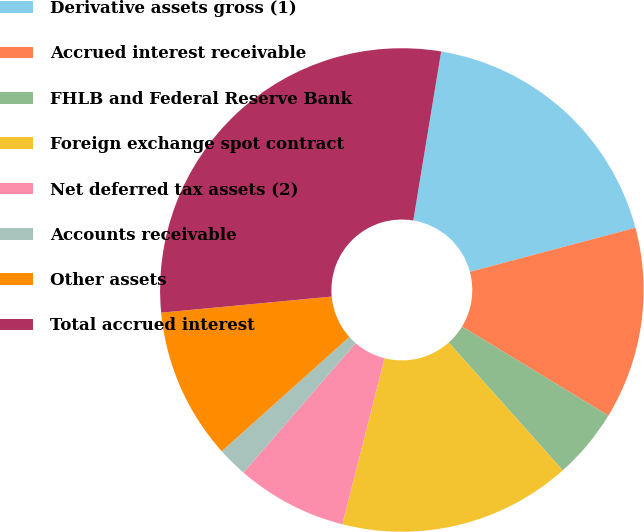Convert chart. <chart><loc_0><loc_0><loc_500><loc_500><pie_chart><fcel>Derivative assets gross (1)<fcel>Accrued interest receivable<fcel>FHLB and Federal Reserve Bank<fcel>Foreign exchange spot contract<fcel>Net deferred tax assets (2)<fcel>Accounts receivable<fcel>Other assets<fcel>Total accrued interest<nl><fcel>18.26%<fcel>12.84%<fcel>4.71%<fcel>15.55%<fcel>7.42%<fcel>2.0%<fcel>10.13%<fcel>29.1%<nl></chart> 